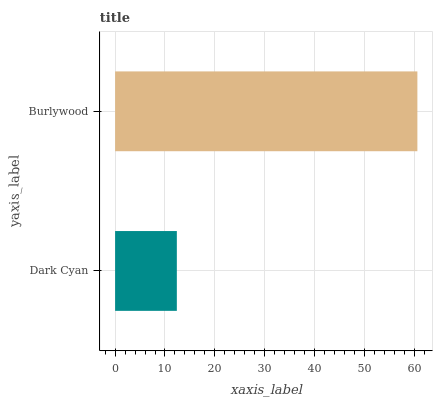Is Dark Cyan the minimum?
Answer yes or no. Yes. Is Burlywood the maximum?
Answer yes or no. Yes. Is Burlywood the minimum?
Answer yes or no. No. Is Burlywood greater than Dark Cyan?
Answer yes or no. Yes. Is Dark Cyan less than Burlywood?
Answer yes or no. Yes. Is Dark Cyan greater than Burlywood?
Answer yes or no. No. Is Burlywood less than Dark Cyan?
Answer yes or no. No. Is Burlywood the high median?
Answer yes or no. Yes. Is Dark Cyan the low median?
Answer yes or no. Yes. Is Dark Cyan the high median?
Answer yes or no. No. Is Burlywood the low median?
Answer yes or no. No. 